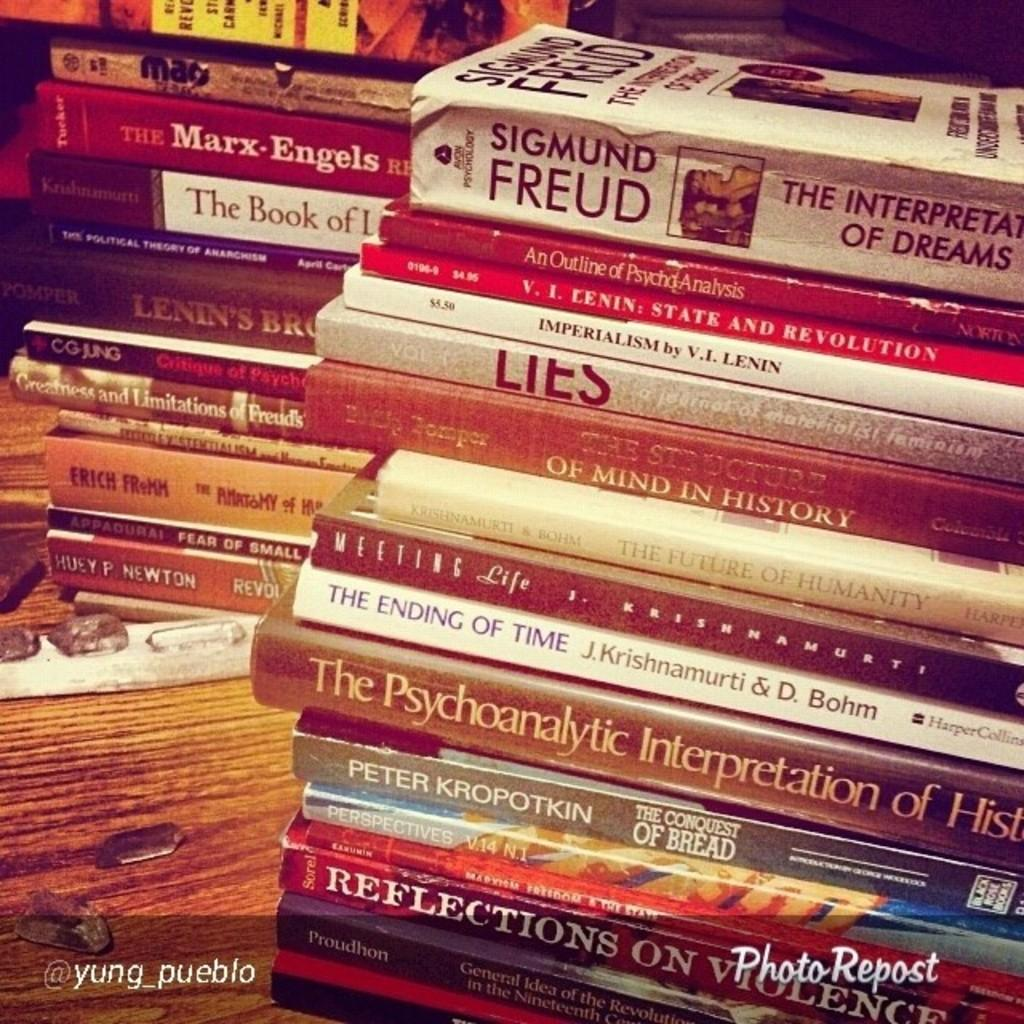<image>
Offer a succinct explanation of the picture presented. A stack of books has one written by Freud at the top. 